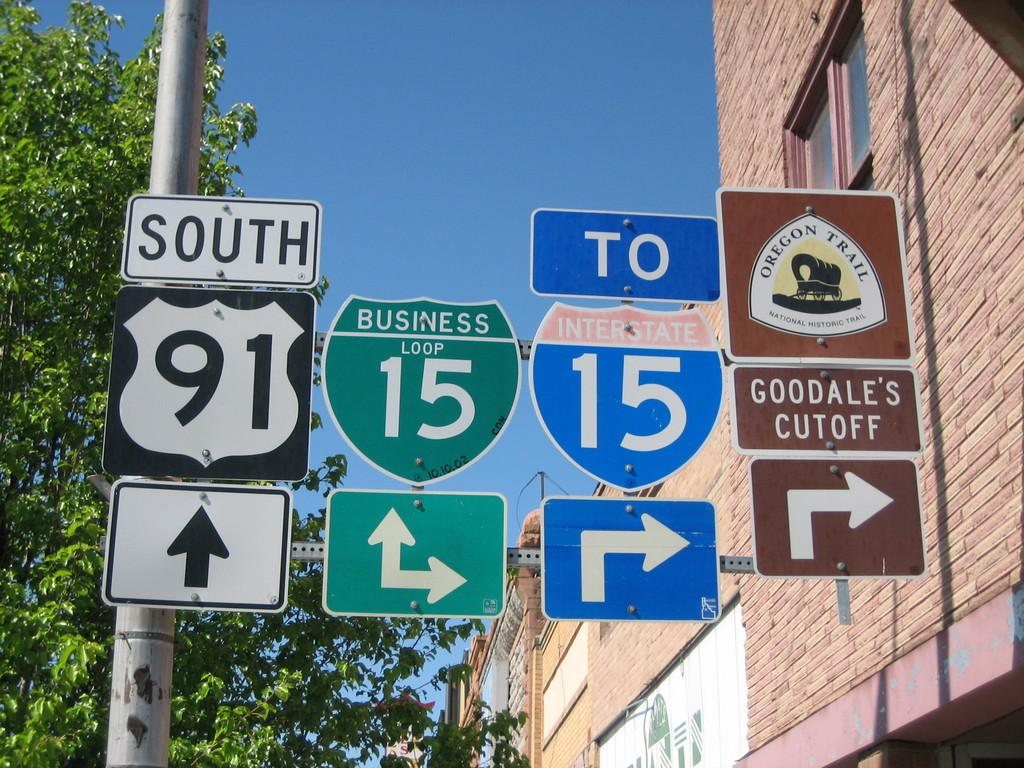Provide a one-sentence caption for the provided image. A picture of a 4 road signs giving directions to goodales cutoff. 